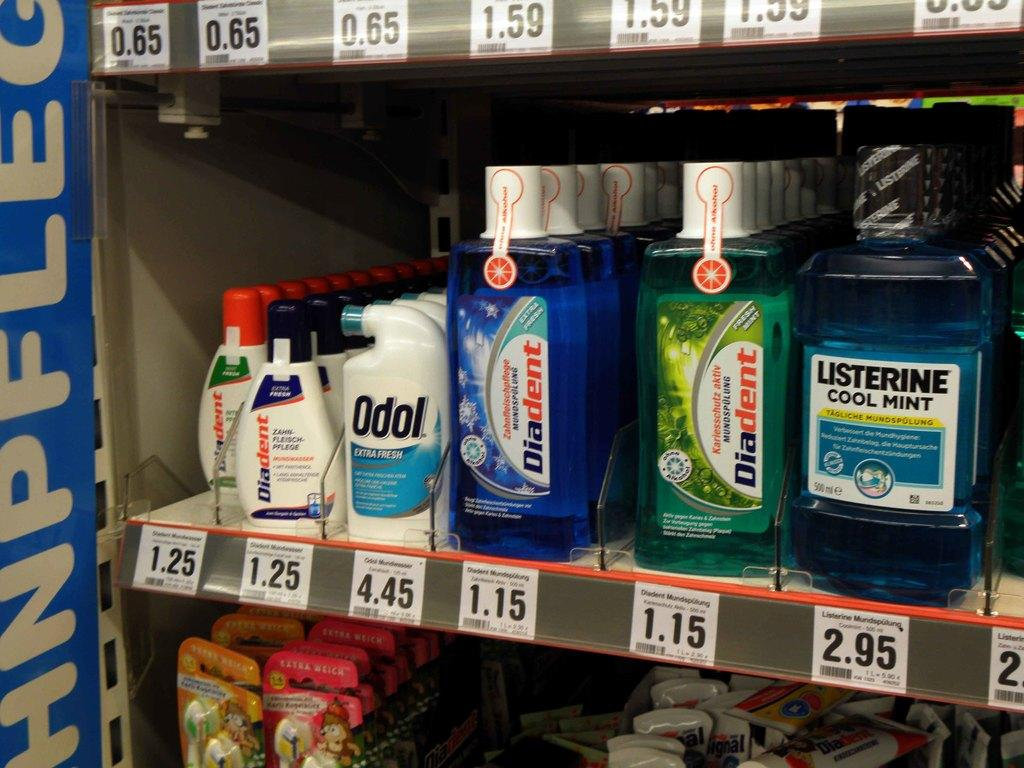What objects can be seen in the image? There are bottles and toothbrushes in the image. How are the bottles and toothbrushes organized? The bottles and toothbrushes are in racks. Are there any additional details about the items in the image? Price tags are visible in the image. What type of bells can be heard ringing in the image? There are no bells present in the image, and therefore no sounds can be heard. 